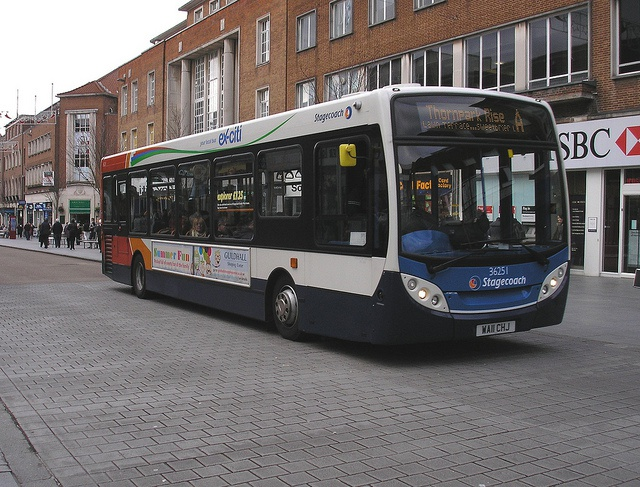Describe the objects in this image and their specific colors. I can see bus in white, black, darkgray, gray, and navy tones, people in white, black, gray, darkgray, and maroon tones, people in white, black, and gray tones, people in white, black, gray, and blue tones, and people in white, black, and gray tones in this image. 